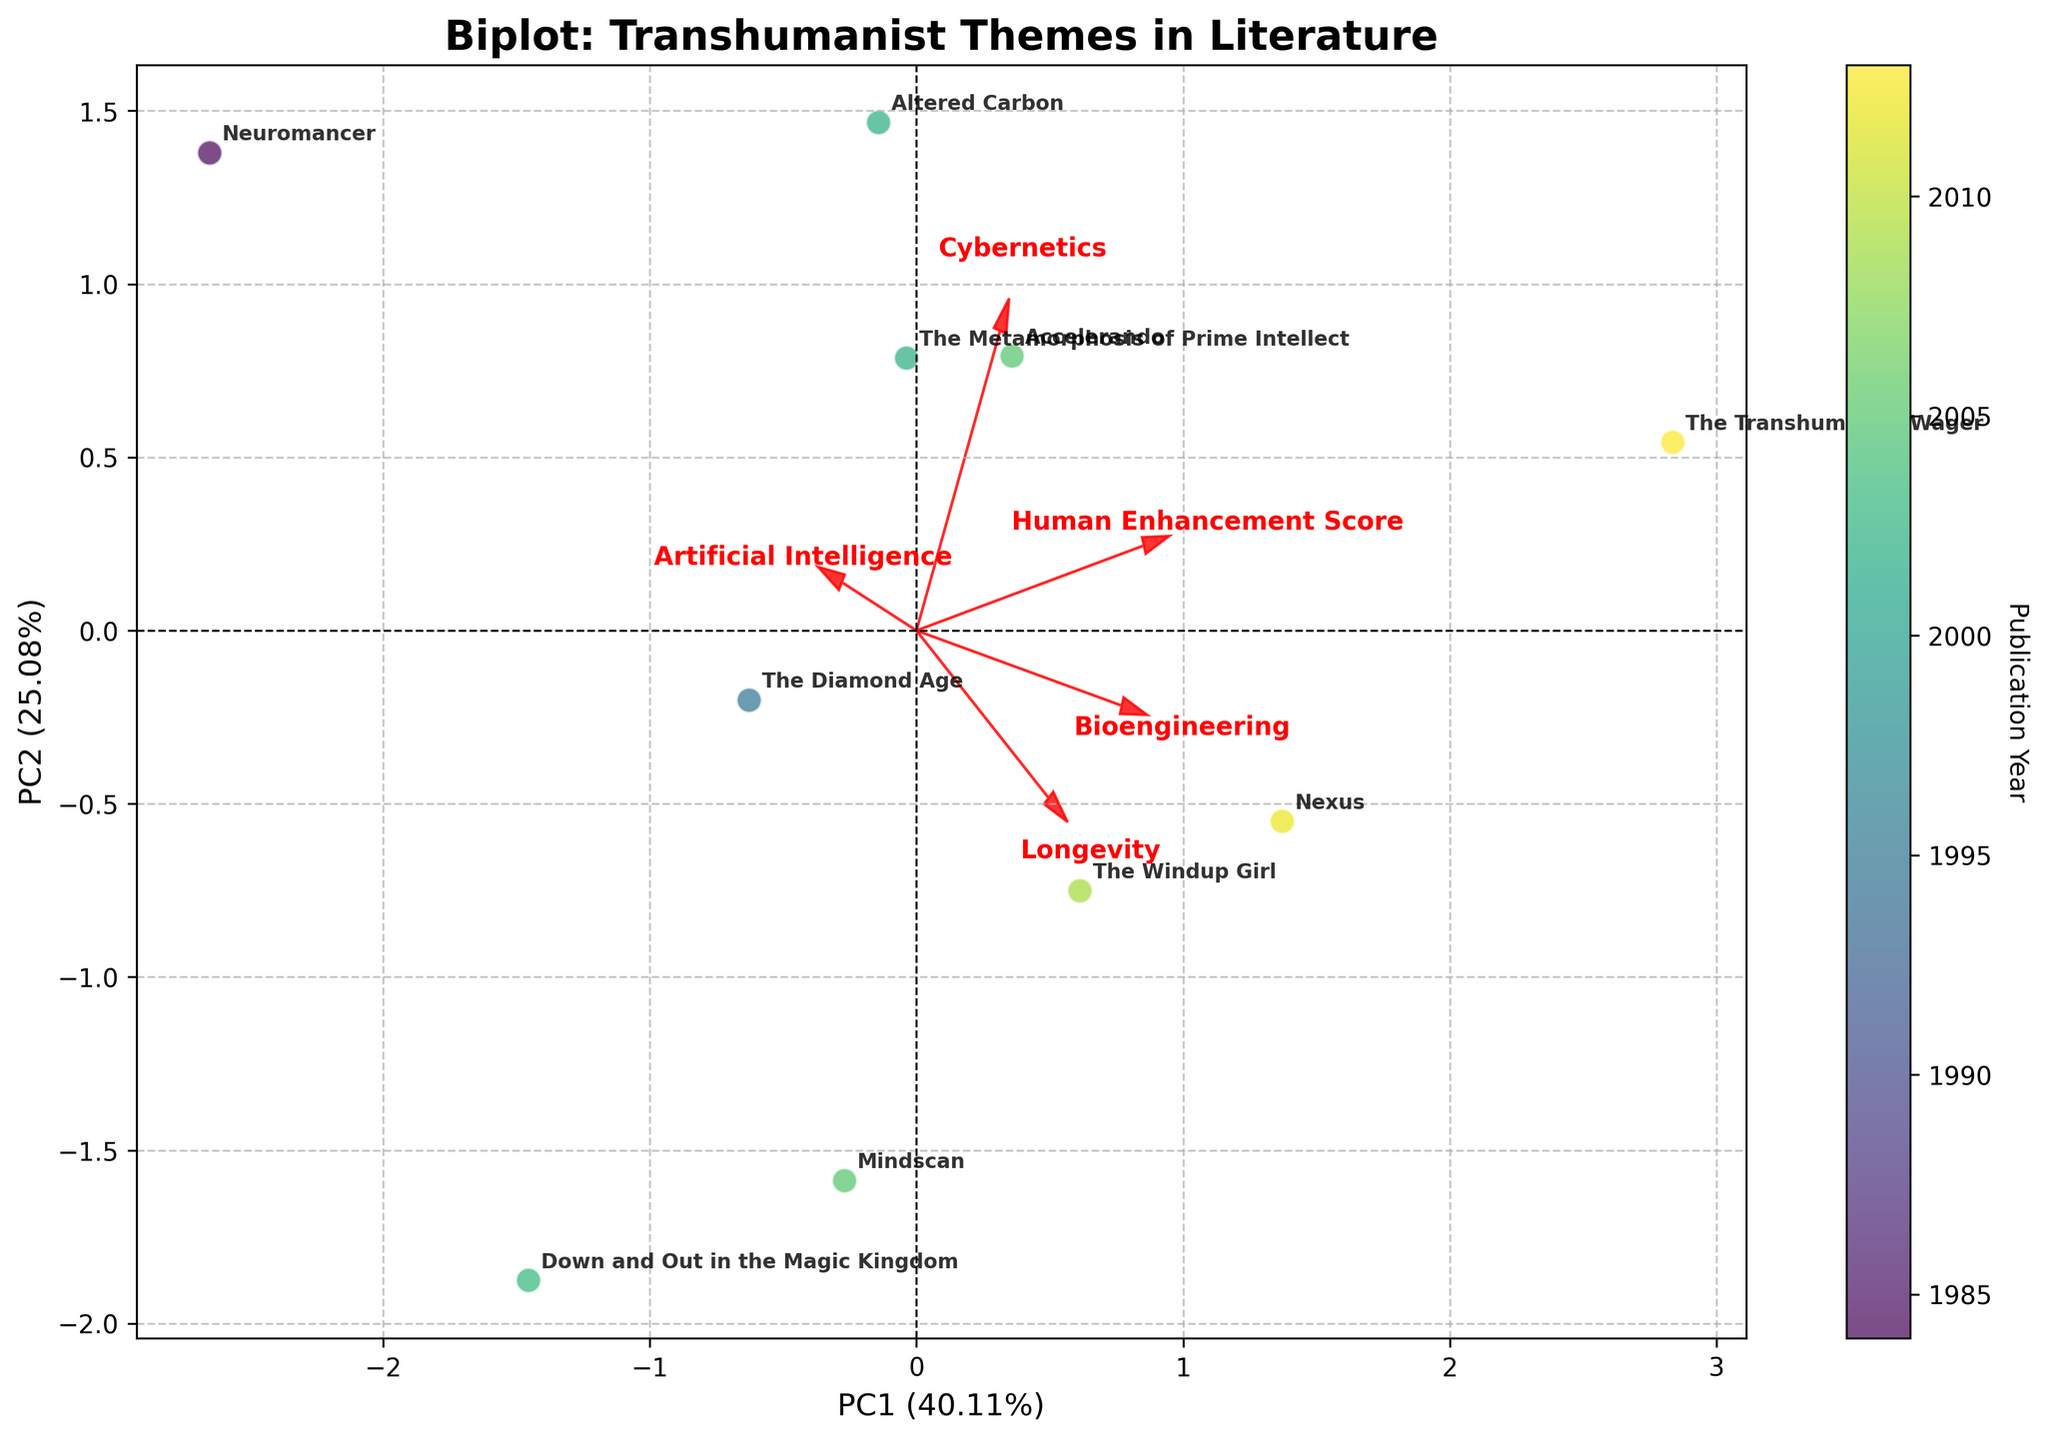Which book has the highest Human Enhancement Score? By looking at the annotations, we can see that "The Transhumanist Wager" is located furthest along the PC1 axis. Its Human Enhancement Score is highest among all the books.
Answer: "The Transhumanist Wager" What are the axes representing? The x-axis represents the first principal component (PC1), and the y-axis represents the second principal component (PC2). These components capture the maximum variance within the dataset, highlighting major patterns and correlations.
Answer: PC1 and PC2 Which theme shows the highest correlation with PC1? By examining the arrows, Cybernetics has the longest vector along PC1, indicating the highest correlation. We see the Cybernetics arrow pointing further along the PC1 axis.
Answer: Cybernetics How do "Neuromancer" and "Accelerando" compare in terms of Artificial Intelligence and Cybernetics themes? "Neuromancer" has a higher PC2 value compared to "Accelerando". By examining the directions of the Artificial Intelligence and Cybernetics arrows, we see that "Accelerando" lies closer to both arrows than "Neuromancer". This indicates "Accelerando" is more correlated with these themes.
Answer: "Accelerando" is more correlated Which publication years have the highest concentration of books? By referring to the color gradient, which indicates publication years, most books are concentrated around the years 2002-2005. We see these years more prominently within the clustered data points.
Answer: 2002-2005 What is the relationship between Bioengineering and Longevity themes in the biplot? The vectors for Bioengineering and Longevity have similar directions and magnitudes, indicating a positive correlation. This means books that focus on Bioengineering also tend to emphasize Longevity.
Answer: Positive correlation Which books are placed nearest to each other on the plot? By observing the plot, "Mindscan" and "Accelerando" are positioned very close to one another, indicating similar thematic elements and publication years.
Answer: "Mindscan" and "Accelerando" How is "The Transhumanist Wager" distinct in terms of themes? "The Transhumanist Wager" has a strong presence along PC1 and PC2, and the directions of the Bioengineering, Longevity, and Cybernetics arrows point towards it. This suggests a higher emphasis on these themes compared to other books.
Answer: Emphasis on Bioengineering, Longevity, and Cybernetics Which theme is least correlated with PC2? By looking at the lengths and directions of the arrows along PC2, Longevity has the shortest vector, showing the least correlation with PC2.
Answer: Longevity 